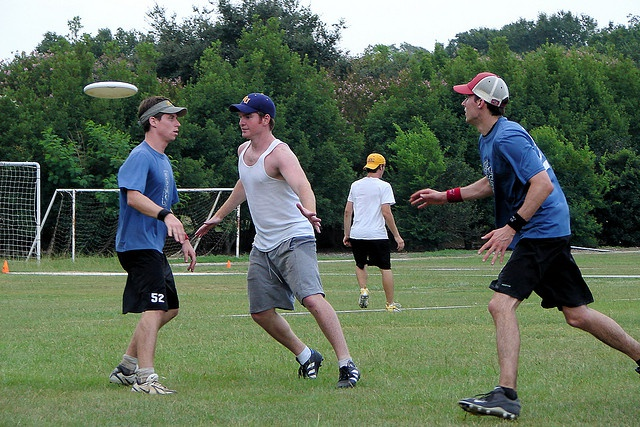Describe the objects in this image and their specific colors. I can see people in white, black, gray, darkgray, and blue tones, people in white, darkgray, gray, and black tones, people in white, black, darkgray, navy, and blue tones, people in white, lavender, black, and gray tones, and frisbee in white, gray, and darkgray tones in this image. 